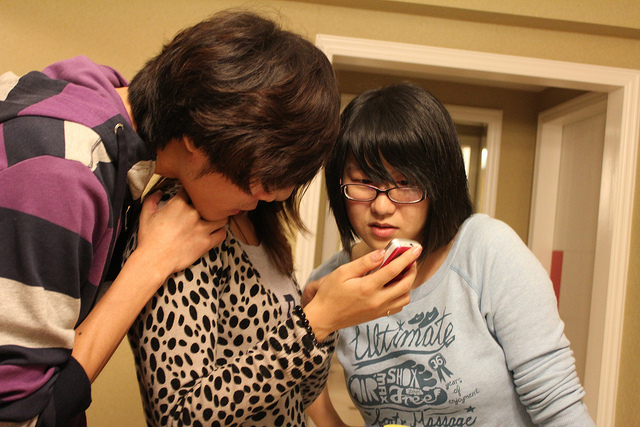Please transcribe the text in this image. Ultimate AIR MAX SHOX 36 Tree Massage 